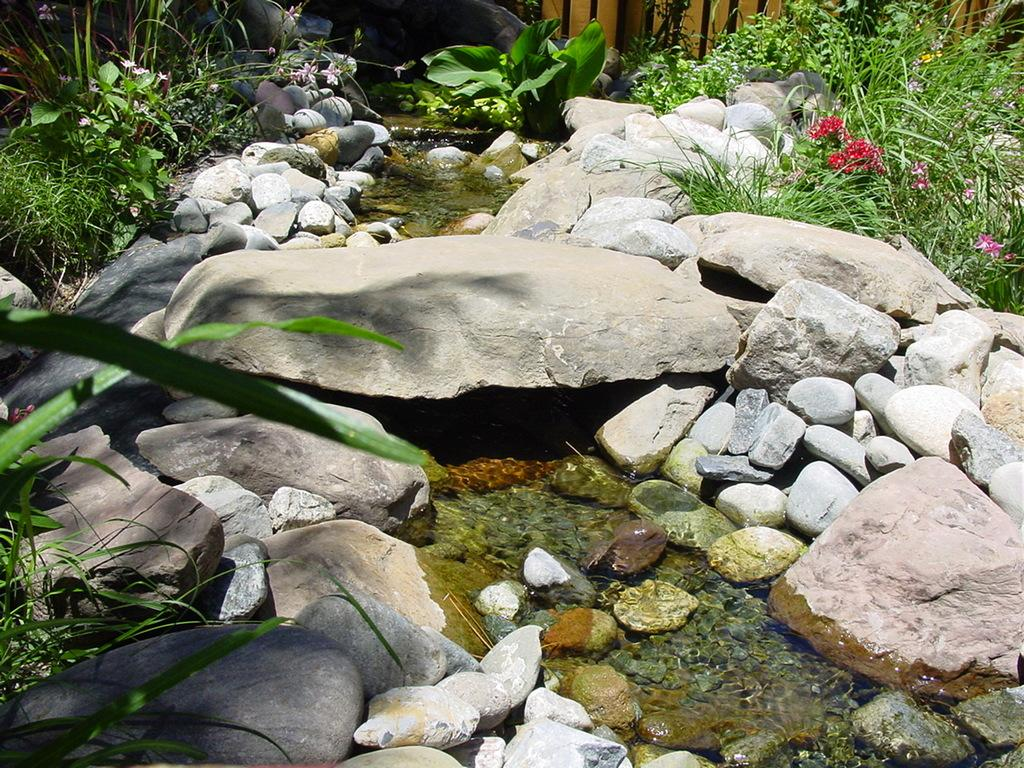What type of natural elements can be seen in the image? There are rocks, stones, water, plants, and flowers visible in the image. What might be used to separate or enclose an area in the image? There is a fence on the backside of the image. What type of legal advice can be sought from the rocks in the image? There are no lawyers or legal advice present in the image; it features natural elements such as rocks, stones, water, plants, and flowers. What type of hair grooming tool can be seen in the image? There is no comb or any hair grooming tool present in the image. 